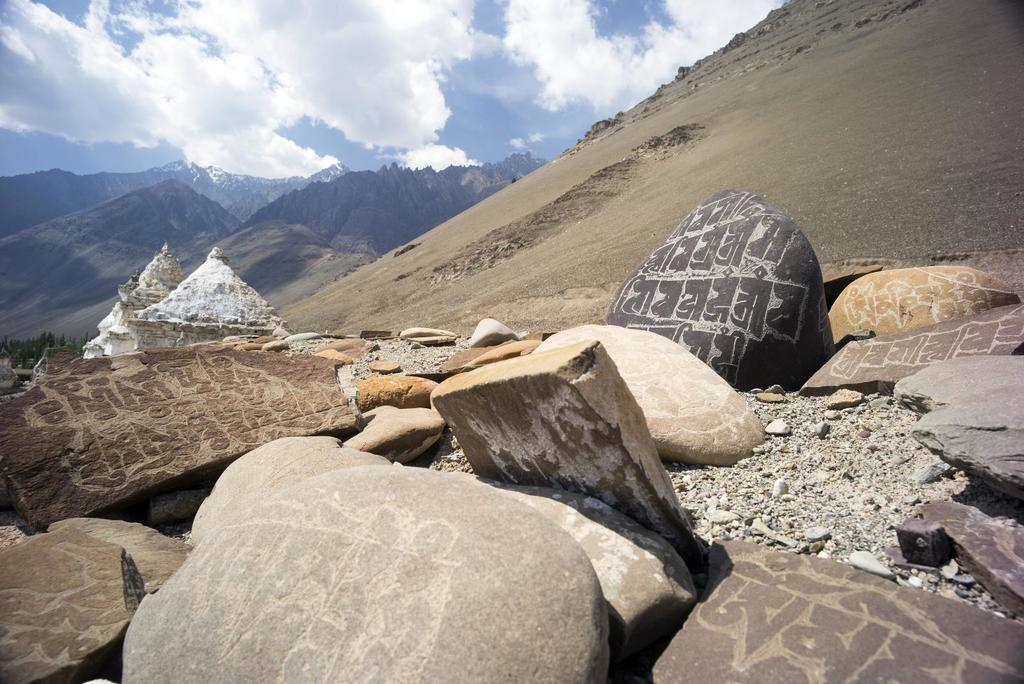What type of natural elements can be seen in the image? There are rocks and stones in the image. What can be seen in the distance in the image? There are hills in the background of the image. What part of the natural environment is visible in the image? The sky is visible in the background of the image. What is the condition of the sky in the image? Clouds are present in the sky. What type of bread is being cooked in the image? There is no bread or cooking activity present in the image. 